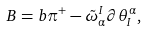<formula> <loc_0><loc_0><loc_500><loc_500>B = b \pi ^ { + } - \tilde { \omega } ^ { I } _ { \alpha } \partial \theta ^ { \alpha } _ { I } ,</formula> 